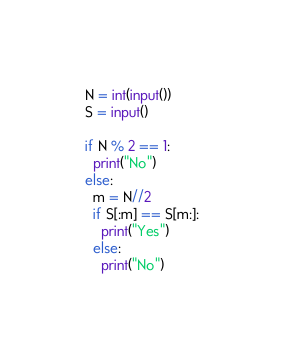<code> <loc_0><loc_0><loc_500><loc_500><_Python_>N = int(input())
S = input()

if N % 2 == 1:
  print("No")
else:
  m = N//2
  if S[:m] == S[m:]:
    print("Yes")
  else:
    print("No")</code> 